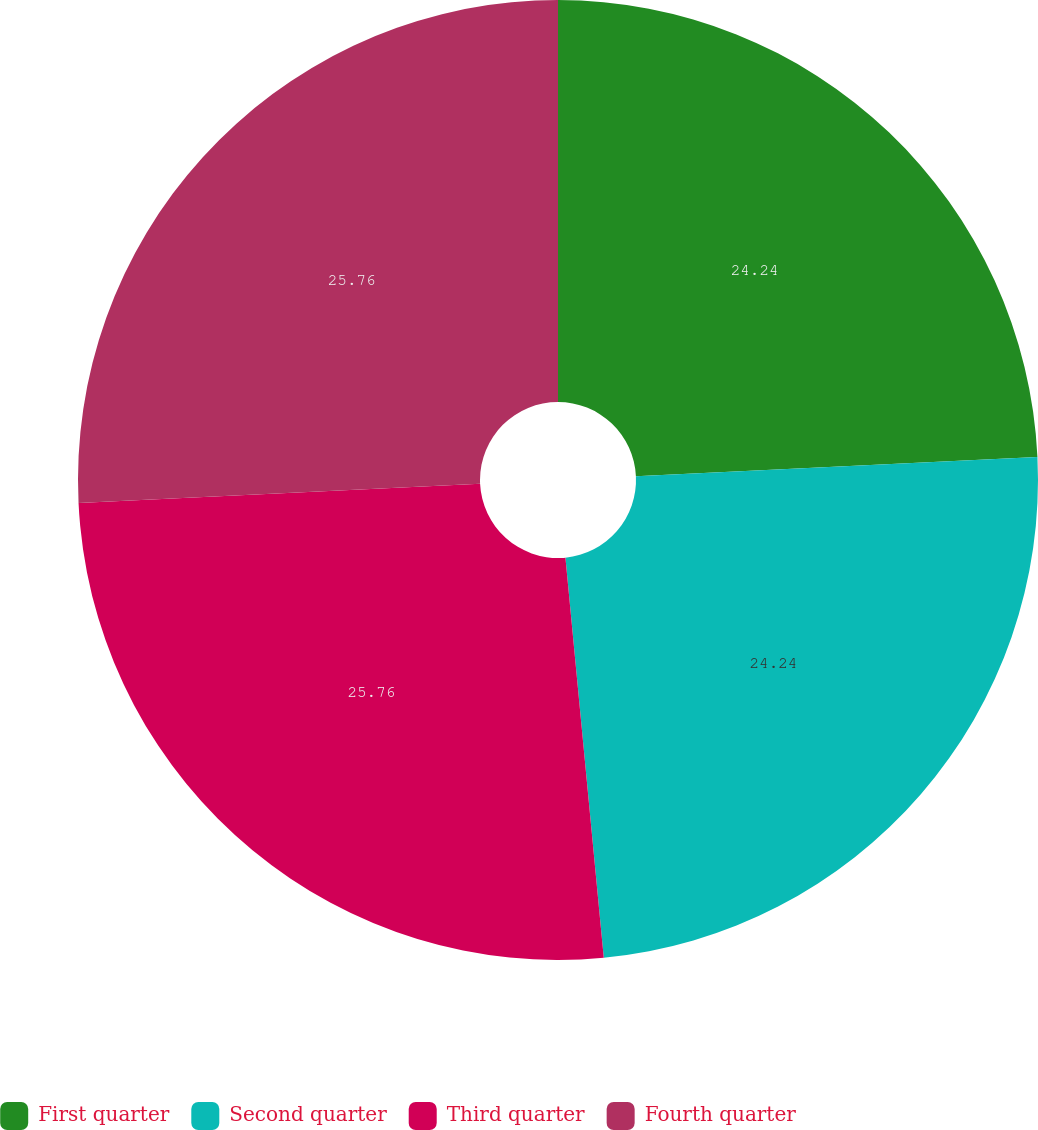Convert chart. <chart><loc_0><loc_0><loc_500><loc_500><pie_chart><fcel>First quarter<fcel>Second quarter<fcel>Third quarter<fcel>Fourth quarter<nl><fcel>24.24%<fcel>24.24%<fcel>25.76%<fcel>25.76%<nl></chart> 